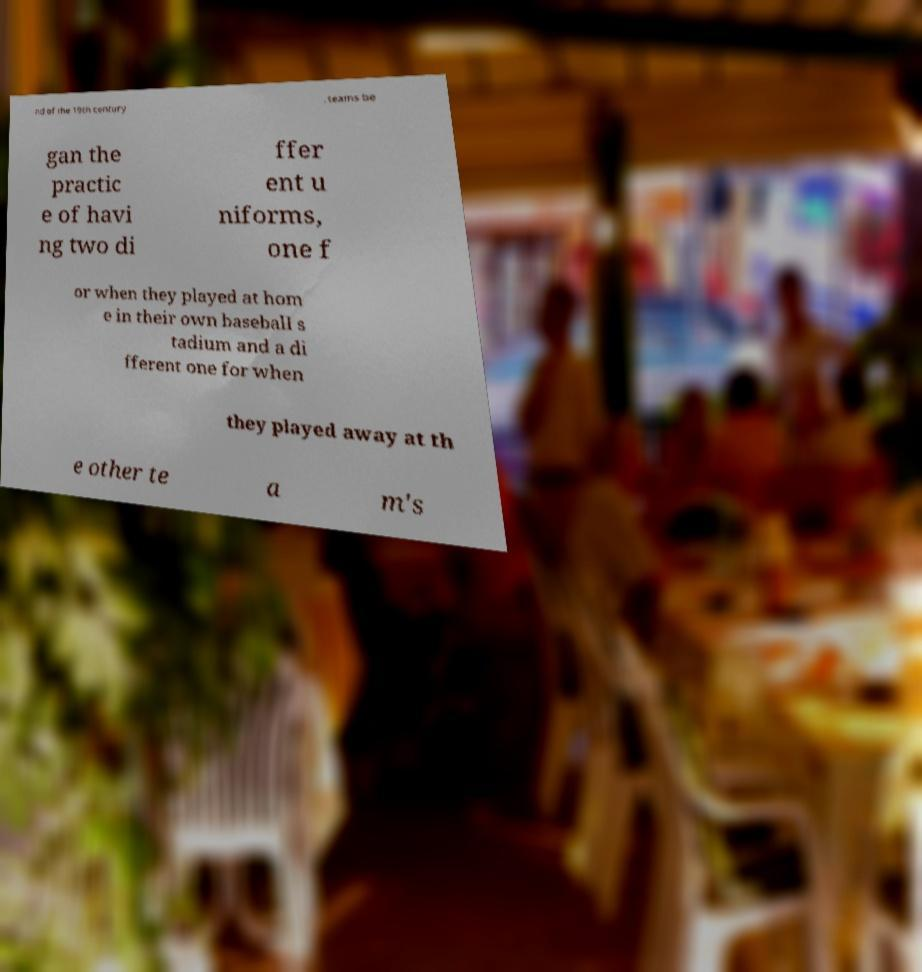For documentation purposes, I need the text within this image transcribed. Could you provide that? nd of the 19th century , teams be gan the practic e of havi ng two di ffer ent u niforms, one f or when they played at hom e in their own baseball s tadium and a di fferent one for when they played away at th e other te a m's 